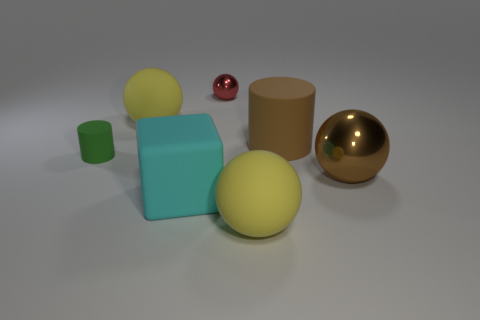Add 3 big brown shiny things. How many objects exist? 10 Subtract all cylinders. How many objects are left? 5 Subtract 1 cyan cubes. How many objects are left? 6 Subtract all green matte objects. Subtract all big cyan rubber things. How many objects are left? 5 Add 6 large cylinders. How many large cylinders are left? 7 Add 6 cyan things. How many cyan things exist? 7 